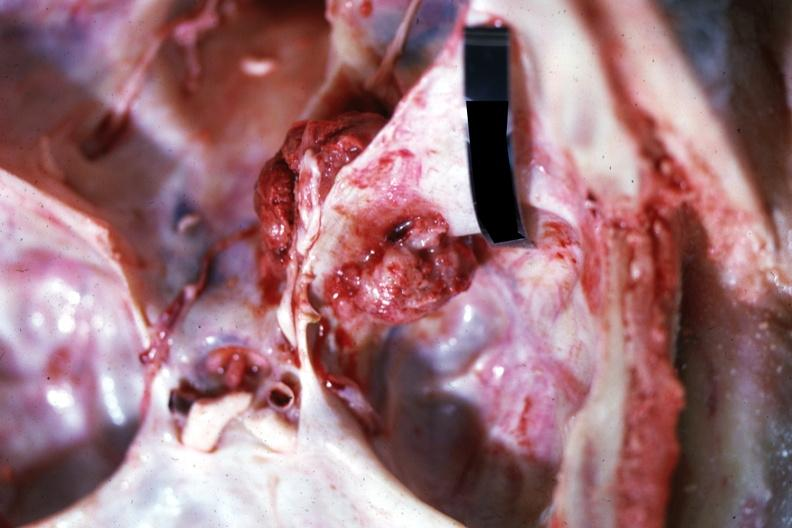s atheromatous embolus present?
Answer the question using a single word or phrase. No 